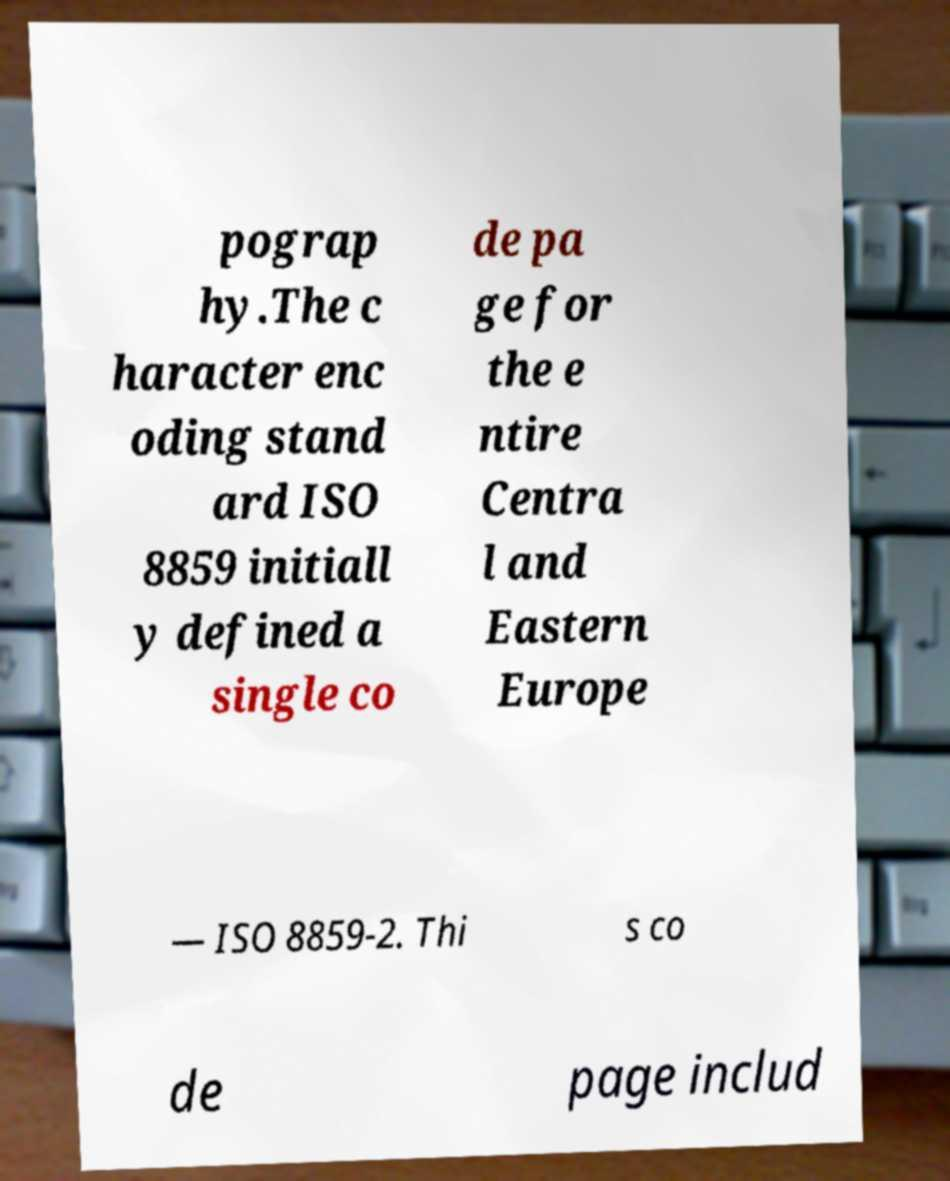What messages or text are displayed in this image? I need them in a readable, typed format. pograp hy.The c haracter enc oding stand ard ISO 8859 initiall y defined a single co de pa ge for the e ntire Centra l and Eastern Europe — ISO 8859-2. Thi s co de page includ 